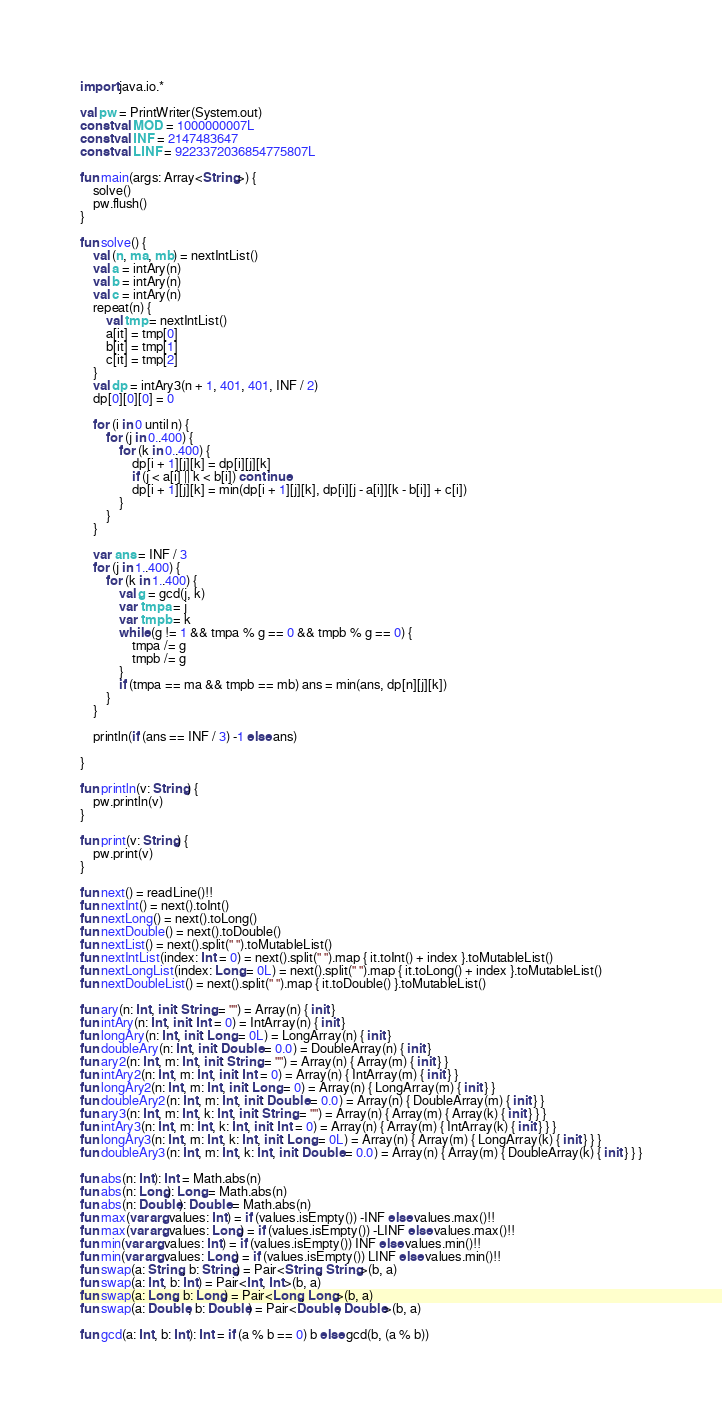Convert code to text. <code><loc_0><loc_0><loc_500><loc_500><_Kotlin_>import java.io.*

val pw = PrintWriter(System.out)
const val MOD = 1000000007L
const val INF = 2147483647
const val LINF = 9223372036854775807L

fun main(args: Array<String>) {
    solve()
    pw.flush()
}

fun solve() {
    val (n, ma, mb) = nextIntList()
    val a = intAry(n)
    val b = intAry(n)
    val c = intAry(n)
    repeat(n) {
        val tmp = nextIntList()
        a[it] = tmp[0]
        b[it] = tmp[1]
        c[it] = tmp[2]
    }
    val dp = intAry3(n + 1, 401, 401, INF / 2)
    dp[0][0][0] = 0

    for (i in 0 until n) {
        for (j in 0..400) {
            for (k in 0..400) {
                dp[i + 1][j][k] = dp[i][j][k]
                if (j < a[i] || k < b[i]) continue
                dp[i + 1][j][k] = min(dp[i + 1][j][k], dp[i][j - a[i]][k - b[i]] + c[i])
            }
        }
    }

    var ans = INF / 3
    for (j in 1..400) {
        for (k in 1..400) {
            val g = gcd(j, k)
            var tmpa = j
            var tmpb = k
            while (g != 1 && tmpa % g == 0 && tmpb % g == 0) {
                tmpa /= g
                tmpb /= g
            }
            if (tmpa == ma && tmpb == mb) ans = min(ans, dp[n][j][k])
        }
    }

    println(if (ans == INF / 3) -1 else ans)

}

fun println(v: String) {
    pw.println(v)
}

fun print(v: String) {
    pw.print(v)
}

fun next() = readLine()!!
fun nextInt() = next().toInt()
fun nextLong() = next().toLong()
fun nextDouble() = next().toDouble()
fun nextList() = next().split(" ").toMutableList()
fun nextIntList(index: Int = 0) = next().split(" ").map { it.toInt() + index }.toMutableList()
fun nextLongList(index: Long = 0L) = next().split(" ").map { it.toLong() + index }.toMutableList()
fun nextDoubleList() = next().split(" ").map { it.toDouble() }.toMutableList()

fun ary(n: Int, init: String = "") = Array(n) { init }
fun intAry(n: Int, init: Int = 0) = IntArray(n) { init }
fun longAry(n: Int, init: Long = 0L) = LongArray(n) { init }
fun doubleAry(n: Int, init: Double = 0.0) = DoubleArray(n) { init }
fun ary2(n: Int, m: Int, init: String = "") = Array(n) { Array(m) { init } }
fun intAry2(n: Int, m: Int, init: Int = 0) = Array(n) { IntArray(m) { init } }
fun longAry2(n: Int, m: Int, init: Long = 0) = Array(n) { LongArray(m) { init } }
fun doubleAry2(n: Int, m: Int, init: Double = 0.0) = Array(n) { DoubleArray(m) { init } }
fun ary3(n: Int, m: Int, k: Int, init: String = "") = Array(n) { Array(m) { Array(k) { init } } }
fun intAry3(n: Int, m: Int, k: Int, init: Int = 0) = Array(n) { Array(m) { IntArray(k) { init } } }
fun longAry3(n: Int, m: Int, k: Int, init: Long = 0L) = Array(n) { Array(m) { LongArray(k) { init } } }
fun doubleAry3(n: Int, m: Int, k: Int, init: Double = 0.0) = Array(n) { Array(m) { DoubleArray(k) { init } } }

fun abs(n: Int): Int = Math.abs(n)
fun abs(n: Long): Long = Math.abs(n)
fun abs(n: Double): Double = Math.abs(n)
fun max(vararg values: Int) = if (values.isEmpty()) -INF else values.max()!!
fun max(vararg values: Long) = if (values.isEmpty()) -LINF else values.max()!!
fun min(vararg values: Int) = if (values.isEmpty()) INF else values.min()!!
fun min(vararg values: Long) = if (values.isEmpty()) LINF else values.min()!!
fun swap(a: String, b: String) = Pair<String, String>(b, a)
fun swap(a: Int, b: Int) = Pair<Int, Int>(b, a)
fun swap(a: Long, b: Long) = Pair<Long, Long>(b, a)
fun swap(a: Double, b: Double) = Pair<Double, Double>(b, a)

fun gcd(a: Int, b: Int): Int = if (a % b == 0) b else gcd(b, (a % b))</code> 